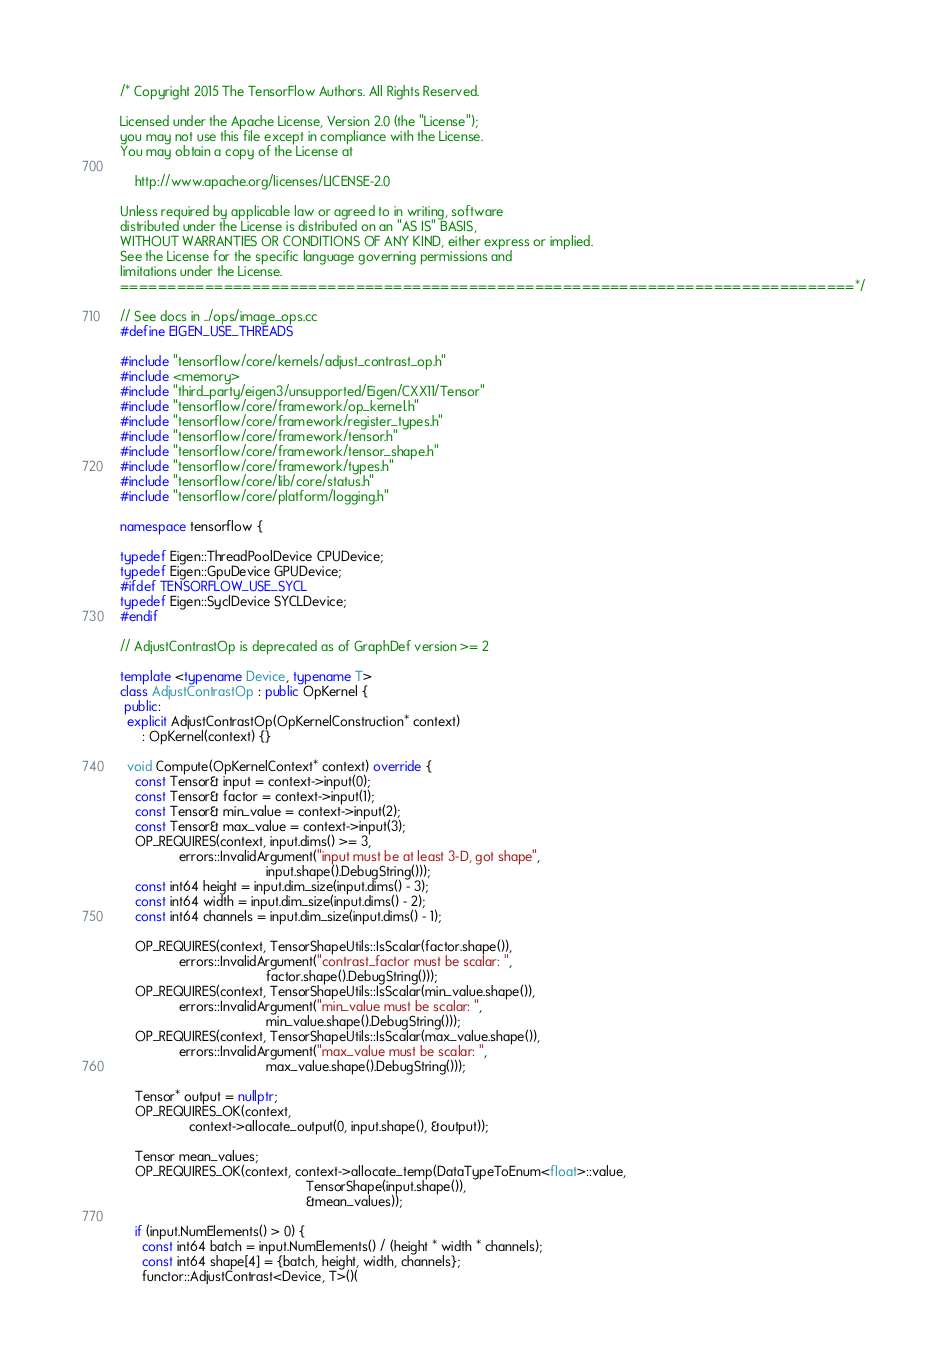Convert code to text. <code><loc_0><loc_0><loc_500><loc_500><_C++_>/* Copyright 2015 The TensorFlow Authors. All Rights Reserved.

Licensed under the Apache License, Version 2.0 (the "License");
you may not use this file except in compliance with the License.
You may obtain a copy of the License at

    http://www.apache.org/licenses/LICENSE-2.0

Unless required by applicable law or agreed to in writing, software
distributed under the License is distributed on an "AS IS" BASIS,
WITHOUT WARRANTIES OR CONDITIONS OF ANY KIND, either express or implied.
See the License for the specific language governing permissions and
limitations under the License.
==============================================================================*/

// See docs in ../ops/image_ops.cc
#define EIGEN_USE_THREADS

#include "tensorflow/core/kernels/adjust_contrast_op.h"
#include <memory>
#include "third_party/eigen3/unsupported/Eigen/CXX11/Tensor"
#include "tensorflow/core/framework/op_kernel.h"
#include "tensorflow/core/framework/register_types.h"
#include "tensorflow/core/framework/tensor.h"
#include "tensorflow/core/framework/tensor_shape.h"
#include "tensorflow/core/framework/types.h"
#include "tensorflow/core/lib/core/status.h"
#include "tensorflow/core/platform/logging.h"

namespace tensorflow {

typedef Eigen::ThreadPoolDevice CPUDevice;
typedef Eigen::GpuDevice GPUDevice;
#ifdef TENSORFLOW_USE_SYCL
typedef Eigen::SyclDevice SYCLDevice;
#endif

// AdjustContrastOp is deprecated as of GraphDef version >= 2

template <typename Device, typename T>
class AdjustContrastOp : public OpKernel {
 public:
  explicit AdjustContrastOp(OpKernelConstruction* context)
      : OpKernel(context) {}

  void Compute(OpKernelContext* context) override {
    const Tensor& input = context->input(0);
    const Tensor& factor = context->input(1);
    const Tensor& min_value = context->input(2);
    const Tensor& max_value = context->input(3);
    OP_REQUIRES(context, input.dims() >= 3,
                errors::InvalidArgument("input must be at least 3-D, got shape",
                                        input.shape().DebugString()));
    const int64 height = input.dim_size(input.dims() - 3);
    const int64 width = input.dim_size(input.dims() - 2);
    const int64 channels = input.dim_size(input.dims() - 1);

    OP_REQUIRES(context, TensorShapeUtils::IsScalar(factor.shape()),
                errors::InvalidArgument("contrast_factor must be scalar: ",
                                        factor.shape().DebugString()));
    OP_REQUIRES(context, TensorShapeUtils::IsScalar(min_value.shape()),
                errors::InvalidArgument("min_value must be scalar: ",
                                        min_value.shape().DebugString()));
    OP_REQUIRES(context, TensorShapeUtils::IsScalar(max_value.shape()),
                errors::InvalidArgument("max_value must be scalar: ",
                                        max_value.shape().DebugString()));

    Tensor* output = nullptr;
    OP_REQUIRES_OK(context,
                   context->allocate_output(0, input.shape(), &output));

    Tensor mean_values;
    OP_REQUIRES_OK(context, context->allocate_temp(DataTypeToEnum<float>::value,
                                                   TensorShape(input.shape()),
                                                   &mean_values));

    if (input.NumElements() > 0) {
      const int64 batch = input.NumElements() / (height * width * channels);
      const int64 shape[4] = {batch, height, width, channels};
      functor::AdjustContrast<Device, T>()(</code> 